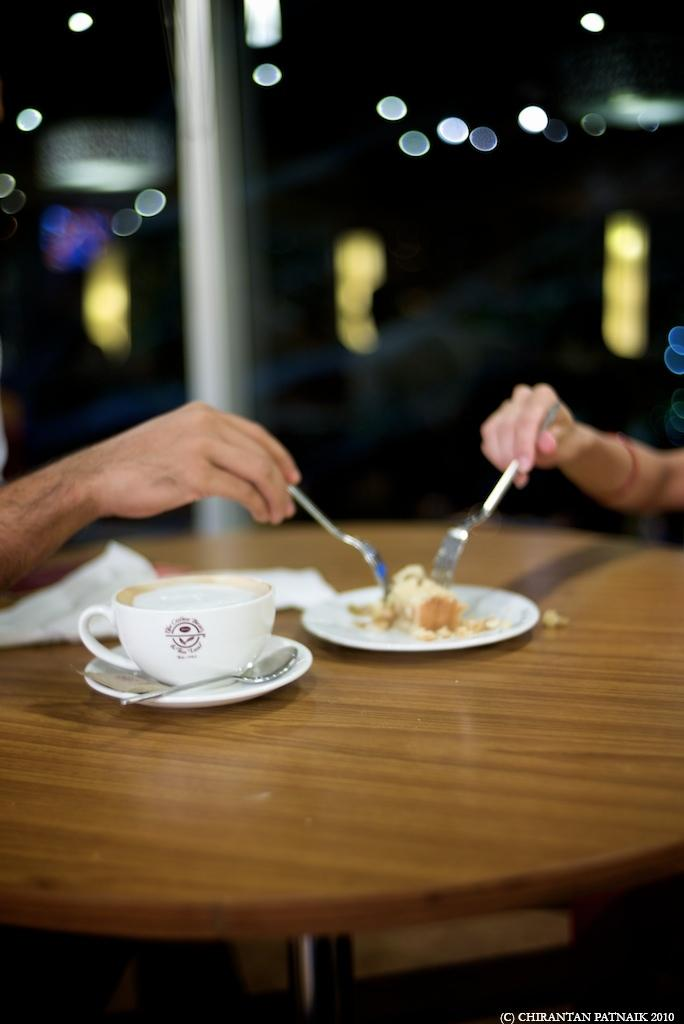What piece of furniture is present in the image? There is a table in the image. What is placed on the table? There is a cup, a saucer, a spoon, and a plate on the table. What is on the plate? There is food on the plate. What utensil is present on the table? There is a spoon on the table. What are the two hands in the image holding? The two hands are holding forks in the image. What type of cracker is being used as a plate in the image? There is no cracker being used as a plate in the image; there is a regular plate with food on it. What type of underwear is visible in the image? There is no underwear visible in the image. 